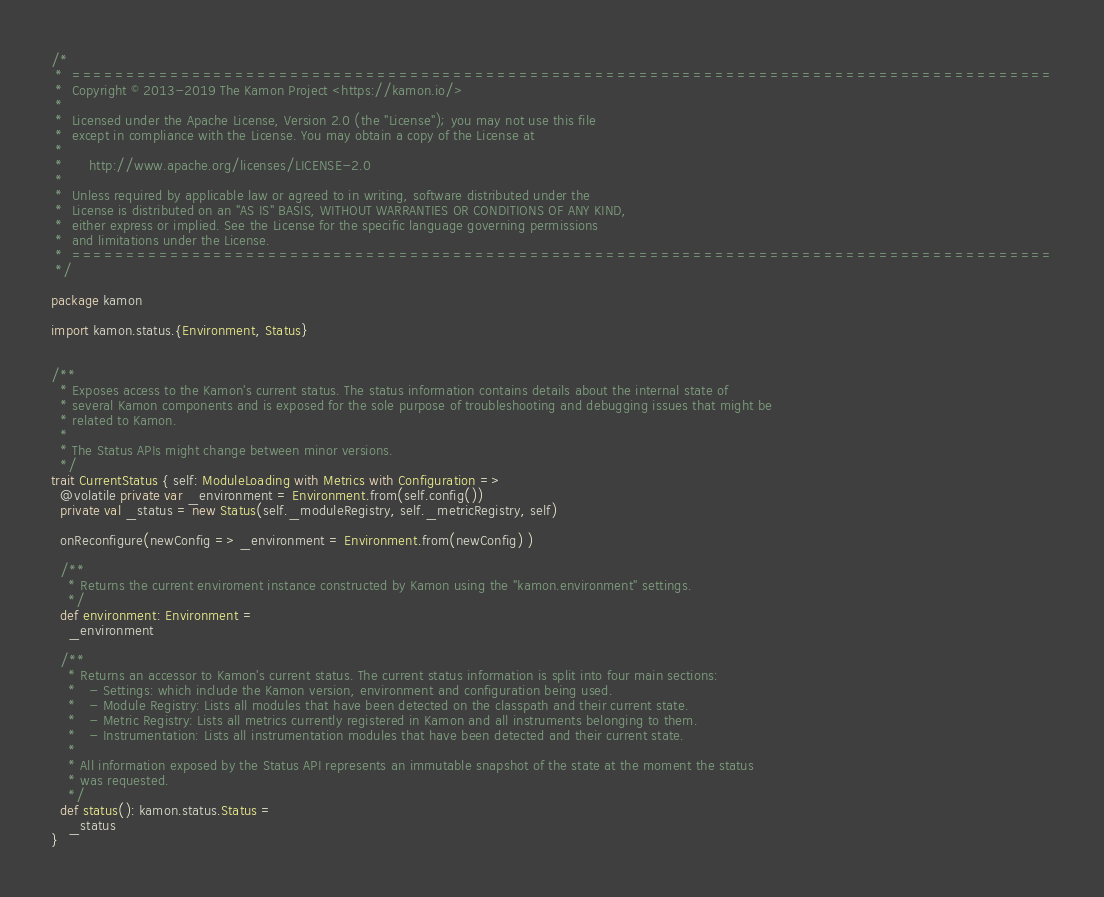Convert code to text. <code><loc_0><loc_0><loc_500><loc_500><_Scala_>/*
 *  ==========================================================================================
 *  Copyright © 2013-2019 The Kamon Project <https://kamon.io/>
 *
 *  Licensed under the Apache License, Version 2.0 (the "License"); you may not use this file
 *  except in compliance with the License. You may obtain a copy of the License at
 *
 *      http://www.apache.org/licenses/LICENSE-2.0
 *
 *  Unless required by applicable law or agreed to in writing, software distributed under the
 *  License is distributed on an "AS IS" BASIS, WITHOUT WARRANTIES OR CONDITIONS OF ANY KIND,
 *  either express or implied. See the License for the specific language governing permissions
 *  and limitations under the License.
 *  ==========================================================================================
 */

package kamon

import kamon.status.{Environment, Status}


/**
  * Exposes access to the Kamon's current status. The status information contains details about the internal state of
  * several Kamon components and is exposed for the sole purpose of troubleshooting and debugging issues that might be
  * related to Kamon.
  *
  * The Status APIs might change between minor versions.
  */
trait CurrentStatus { self: ModuleLoading with Metrics with Configuration =>
  @volatile private var _environment = Environment.from(self.config())
  private val _status = new Status(self._moduleRegistry, self._metricRegistry, self)

  onReconfigure(newConfig => _environment = Environment.from(newConfig) )

  /**
    * Returns the current enviroment instance constructed by Kamon using the "kamon.environment" settings.
    */
  def environment: Environment =
    _environment

  /**
    * Returns an accessor to Kamon's current status. The current status information is split into four main sections:
    *   - Settings: which include the Kamon version, environment and configuration being used.
    *   - Module Registry: Lists all modules that have been detected on the classpath and their current state.
    *   - Metric Registry: Lists all metrics currently registered in Kamon and all instruments belonging to them.
    *   - Instrumentation: Lists all instrumentation modules that have been detected and their current state.
    *
    * All information exposed by the Status API represents an immutable snapshot of the state at the moment the status
    * was requested.
    */
  def status(): kamon.status.Status =
    _status
}
</code> 